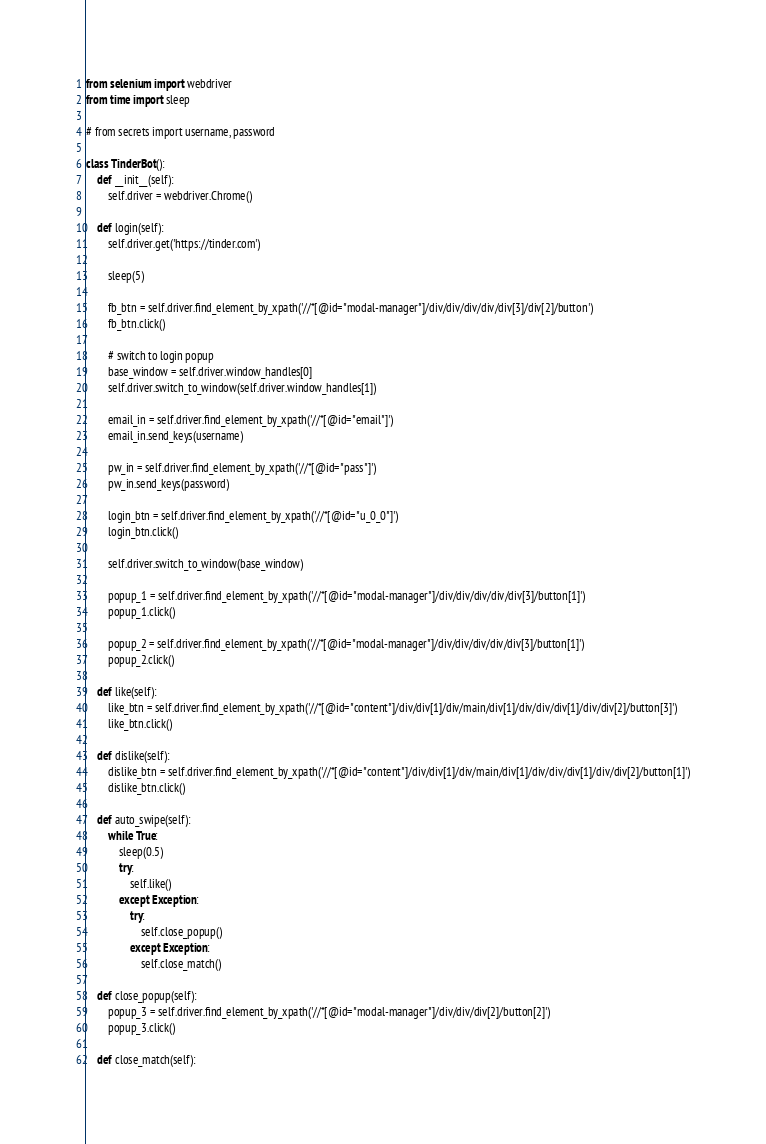<code> <loc_0><loc_0><loc_500><loc_500><_Python_>from selenium import webdriver
from time import sleep

# from secrets import username, password

class TinderBot():
    def __init__(self):
        self.driver = webdriver.Chrome()

    def login(self):
        self.driver.get('https://tinder.com')

        sleep(5)

        fb_btn = self.driver.find_element_by_xpath('//*[@id="modal-manager"]/div/div/div/div/div[3]/div[2]/button')
        fb_btn.click()

        # switch to login popup
        base_window = self.driver.window_handles[0]
        self.driver.switch_to_window(self.driver.window_handles[1])

        email_in = self.driver.find_element_by_xpath('//*[@id="email"]')
        email_in.send_keys(username)

        pw_in = self.driver.find_element_by_xpath('//*[@id="pass"]')
        pw_in.send_keys(password)

        login_btn = self.driver.find_element_by_xpath('//*[@id="u_0_0"]')
        login_btn.click()

        self.driver.switch_to_window(base_window)

        popup_1 = self.driver.find_element_by_xpath('//*[@id="modal-manager"]/div/div/div/div/div[3]/button[1]')
        popup_1.click()

        popup_2 = self.driver.find_element_by_xpath('//*[@id="modal-manager"]/div/div/div/div/div[3]/button[1]')
        popup_2.click()

    def like(self):
        like_btn = self.driver.find_element_by_xpath('//*[@id="content"]/div/div[1]/div/main/div[1]/div/div/div[1]/div/div[2]/button[3]')
        like_btn.click()

    def dislike(self):
        dislike_btn = self.driver.find_element_by_xpath('//*[@id="content"]/div/div[1]/div/main/div[1]/div/div/div[1]/div/div[2]/button[1]')
        dislike_btn.click()

    def auto_swipe(self):
        while True:
            sleep(0.5)
            try:
                self.like()
            except Exception:
                try:
                    self.close_popup()
                except Exception:
                    self.close_match()

    def close_popup(self):
        popup_3 = self.driver.find_element_by_xpath('//*[@id="modal-manager"]/div/div/div[2]/button[2]')
        popup_3.click()

    def close_match(self):</code> 